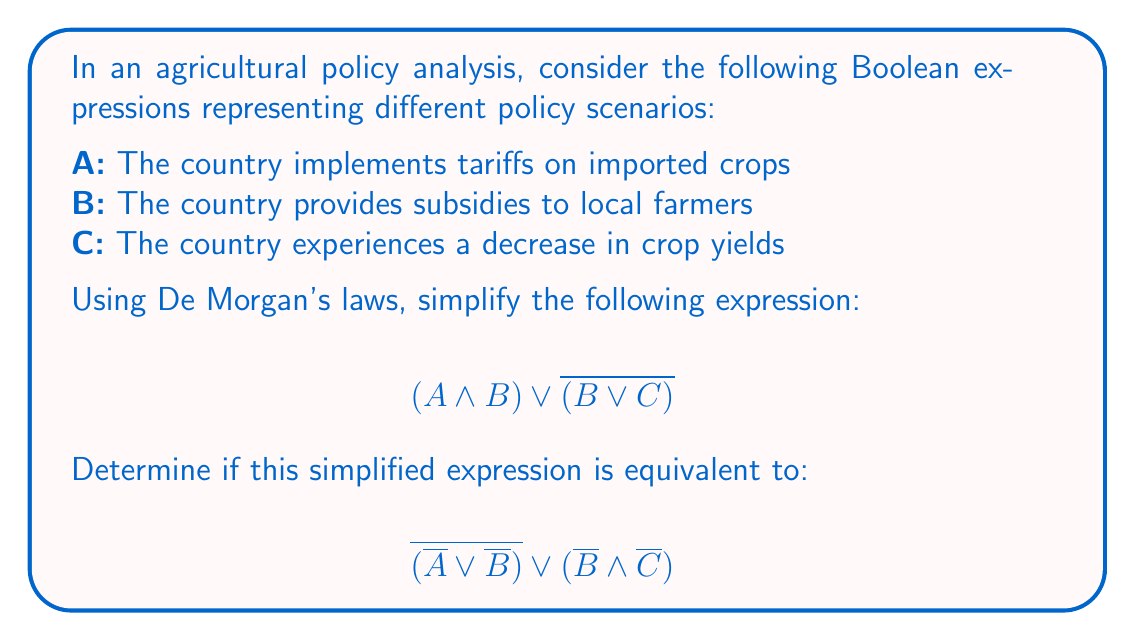Help me with this question. Let's approach this step-by-step:

1) First, let's apply De Morgan's law to the second part of the original expression:

   $$(A \land B) \lor \overline{(B \lor C)}$$
   $$(A \land B) \lor (\overline{B} \land \overline{C})$$

2) Now we have simplified the original expression. Let's compare this to the given expression:

   $$\overline{(\overline{A} \lor \overline{B})} \lor ({\overline{B}} \land {\overline{C}})$$

3) Let's apply De Morgan's law to the first part of this expression:

   $$(\overline{\overline{A}} \land \overline{\overline{B}}) \lor ({\overline{B}} \land {\overline{C}})$$
   $$(A \land B) \lor ({\overline{B}} \land {\overline{C}})$$

4) We can see that this is identical to our simplified original expression.

5) Therefore, the two expressions are equivalent.

This equivalence demonstrates how complex agricultural policy scenarios can be represented and manipulated using Boolean algebra, allowing for clearer analysis of policy interactions and outcomes.
Answer: Yes, the expressions are equivalent. 